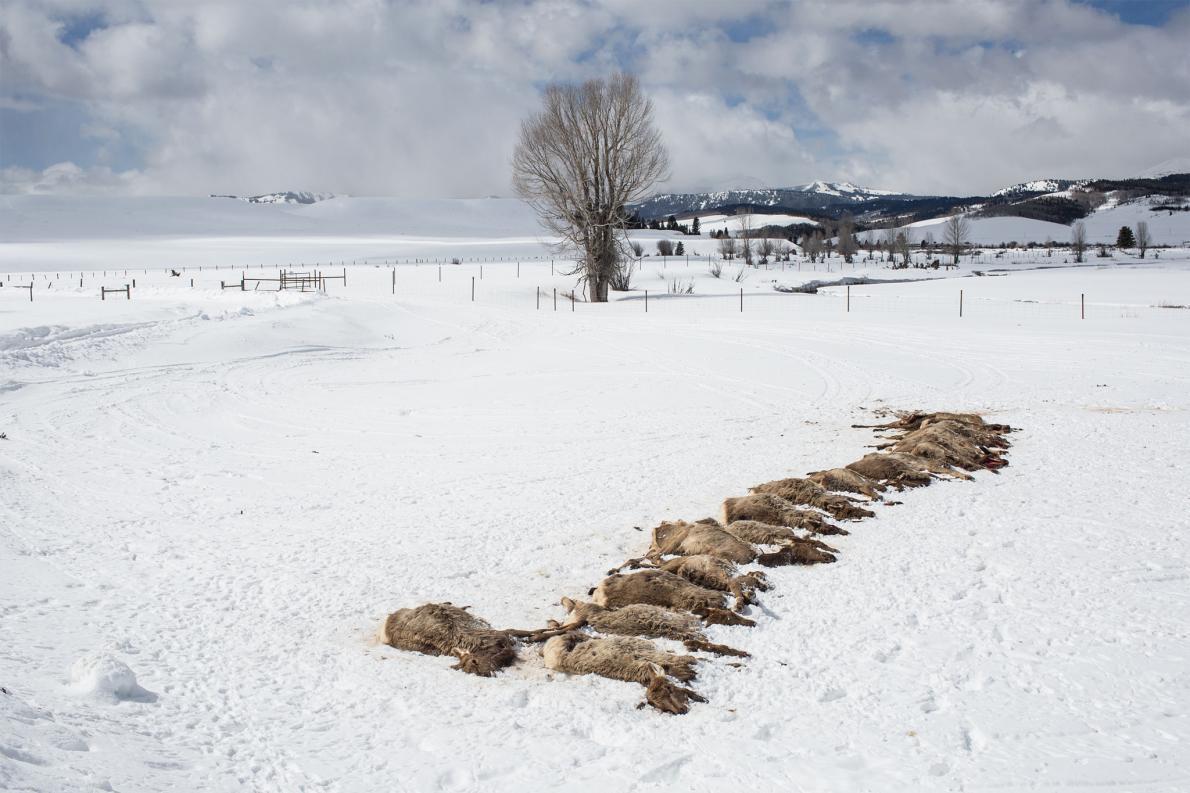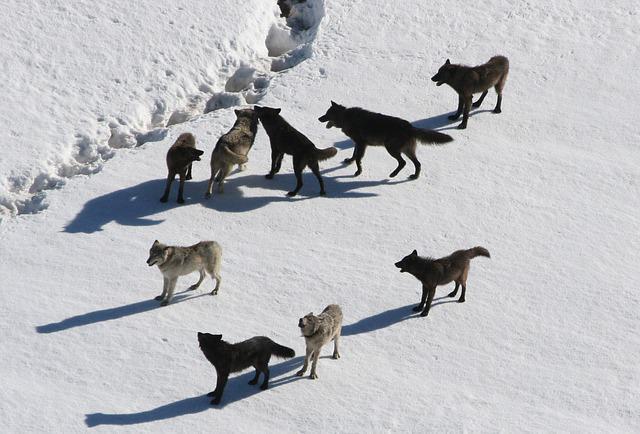The first image is the image on the left, the second image is the image on the right. For the images displayed, is the sentence "there are 5 wolves running in the snow in the image pair" factually correct? Answer yes or no. No. 